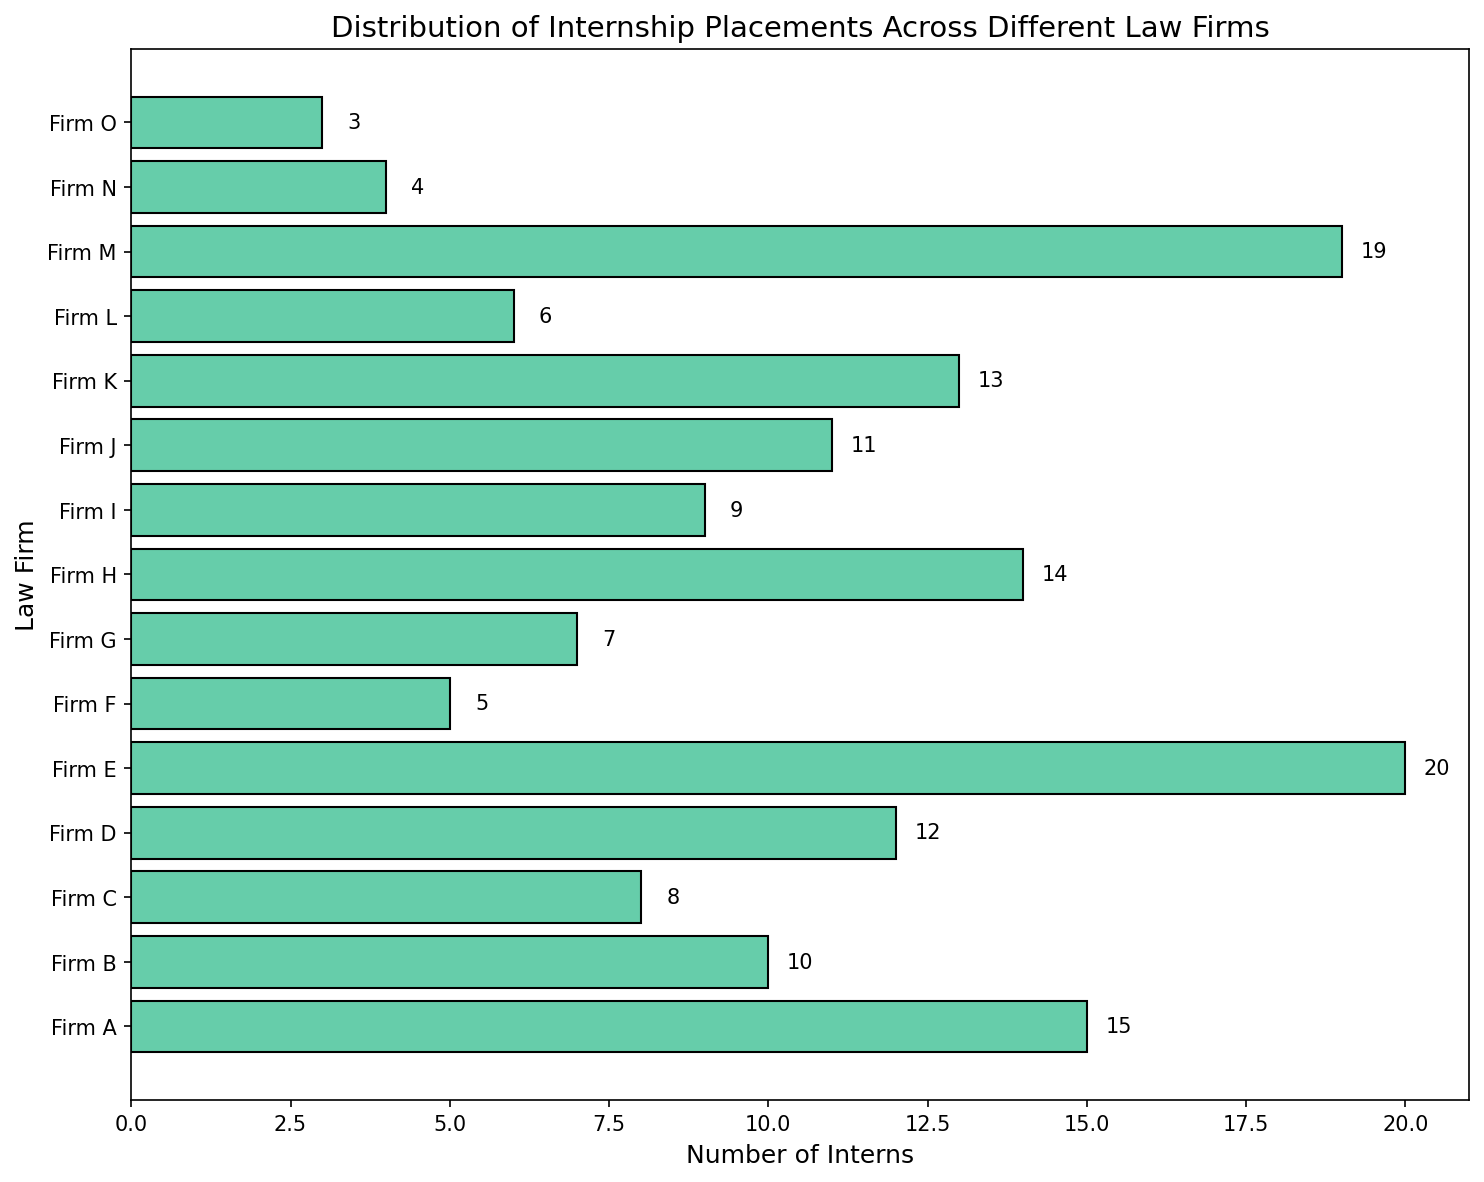Which law firm has the highest number of interns? Reviewing the chart, Firm E has the longest bar extending to the right and a value of 20 interns, which is the highest among all the firms.
Answer: Firm E Which law firm has the lowest number of interns? By looking at the chart, Firm O has the shortest bar with a value of 3 interns, indicating the lowest number among all the firms.
Answer: Firm O How many more interns does Firm B have compared to Firm F? Firm B has 10 interns, while Firm F has 5. Subtracting the interns in Firm F from Firm B, 10 - 5, gives 5.
Answer: 5 What is the total number of interns in Firms A, B, and C? Add the number of interns in Firm A (15), Firm B (10), and Firm C (8) to get the total: 15 + 10 + 8 = 33.
Answer: 33 Calculate the average number of interns per firm. Sum the total number of interns from all firms: 15 + 10 + 8 + 12 + 20 + 5 + 7 + 14 + 9 + 11 + 13 + 6 + 19 + 4 + 3 = 156. Divide this by the number of firms, which is 15. So, 156 / 15 = 10.4.
Answer: 10.4 Which firms have more or equal number of interns than the average number? The average number of interns is 10.4. Firms A (15), B (10), D (12), E (20), H (14), J (11), K (13), and M (19) have intern counts that are equal to or greater than 10.4.
Answer: Firms A, B, D, E, H, J, K, M What is the difference in the number of interns between the firms with the most and least interns? Firm E has the most interns (20), and Firm O has the least (3). Subtracting these, 20 - 3, provides the difference: 17.
Answer: 17 How many firms have fewer than 10 interns? From the chart, the firms with fewer than 10 interns are Firm C (8), Firm F (5), Firm G (7), Firm I (9), Firm L (6), Firm N (4), and Firm O (3). Counting these, there are 7 firms.
Answer: 7 Which firms have precisely 13 interns? By examining the chart, the firm with exactly 13 interns is Firm K.
Answer: Firm K What proportion of the total interns are placed in Firm M? Firm M has 19 interns, and the total number of interns across all firms is 156. The proportion is calculated as 19 / 156 = 0.1218, which can be approximated to 12.18%.
Answer: 12.18% 